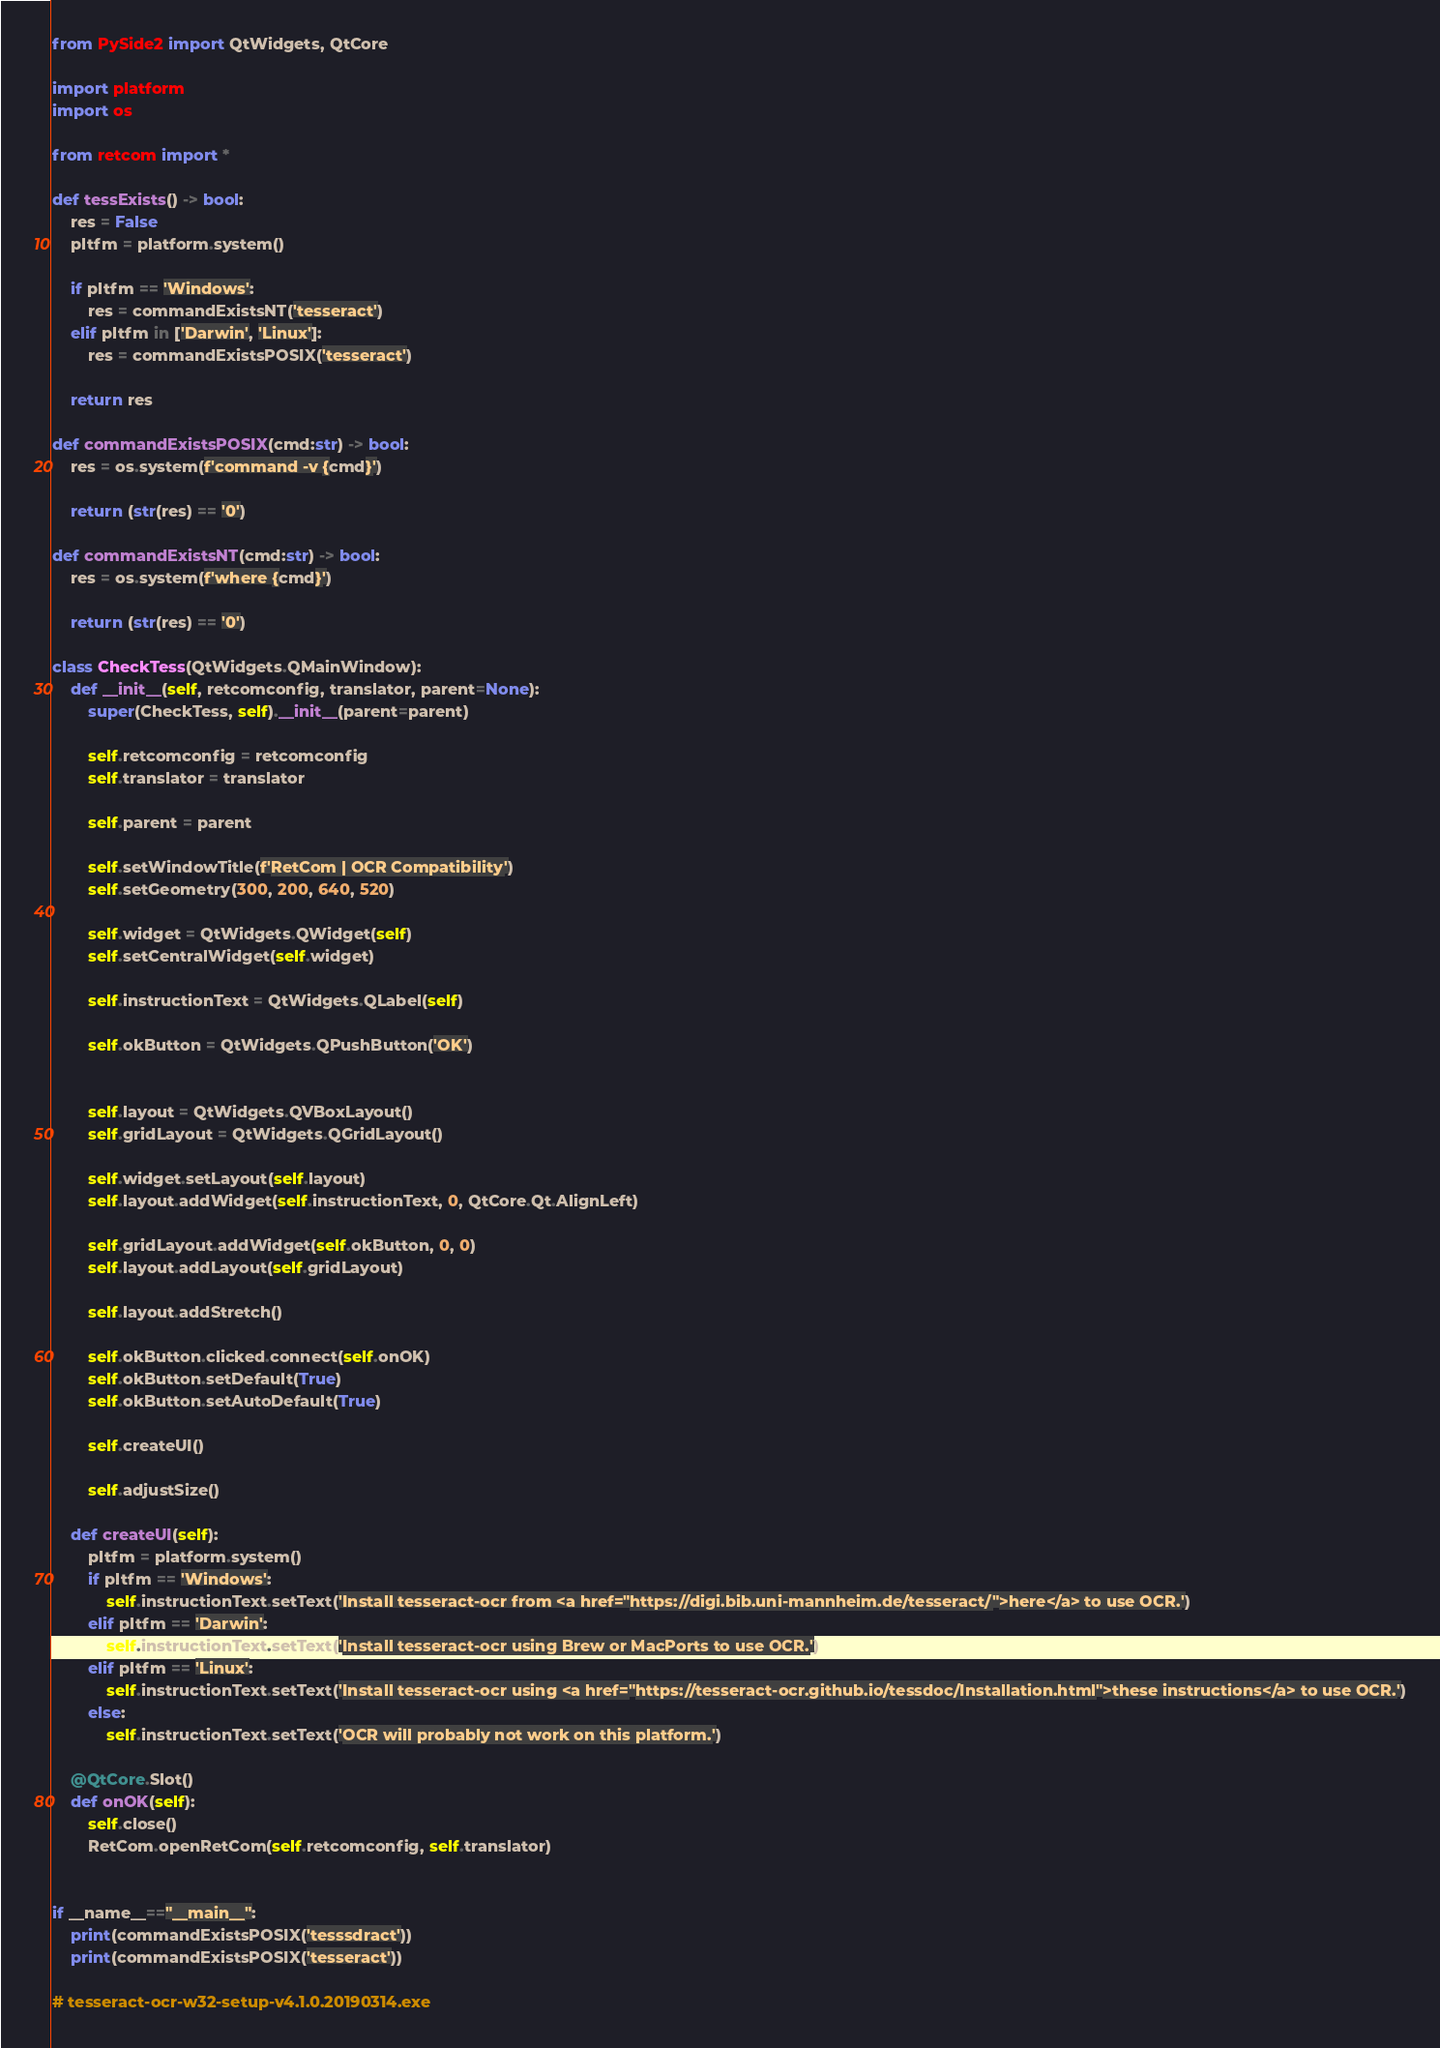Convert code to text. <code><loc_0><loc_0><loc_500><loc_500><_Python_>from PySide2 import QtWidgets, QtCore

import platform
import os

from retcom import *

def tessExists() -> bool:
    res = False
    pltfm = platform.system()

    if pltfm == 'Windows':
        res = commandExistsNT('tesseract')
    elif pltfm in ['Darwin', 'Linux']:
        res = commandExistsPOSIX('tesseract')

    return res

def commandExistsPOSIX(cmd:str) -> bool:
    res = os.system(f'command -v {cmd}')

    return (str(res) == '0')

def commandExistsNT(cmd:str) -> bool:
    res = os.system(f'where {cmd}')

    return (str(res) == '0')

class CheckTess(QtWidgets.QMainWindow):
    def __init__(self, retcomconfig, translator, parent=None):
        super(CheckTess, self).__init__(parent=parent)

        self.retcomconfig = retcomconfig
        self.translator = translator

        self.parent = parent

        self.setWindowTitle(f'RetCom | OCR Compatibility')
        self.setGeometry(300, 200, 640, 520)

        self.widget = QtWidgets.QWidget(self)
        self.setCentralWidget(self.widget)

        self.instructionText = QtWidgets.QLabel(self)

        self.okButton = QtWidgets.QPushButton('OK')


        self.layout = QtWidgets.QVBoxLayout()
        self.gridLayout = QtWidgets.QGridLayout()

        self.widget.setLayout(self.layout)
        self.layout.addWidget(self.instructionText, 0, QtCore.Qt.AlignLeft)

        self.gridLayout.addWidget(self.okButton, 0, 0)
        self.layout.addLayout(self.gridLayout)

        self.layout.addStretch()

        self.okButton.clicked.connect(self.onOK)
        self.okButton.setDefault(True)
        self.okButton.setAutoDefault(True)

        self.createUI()

        self.adjustSize()

    def createUI(self):
        pltfm = platform.system()
        if pltfm == 'Windows':
            self.instructionText.setText('Install tesseract-ocr from <a href="https://digi.bib.uni-mannheim.de/tesseract/">here</a> to use OCR.')
        elif pltfm == 'Darwin':
            self.instructionText.setText('Install tesseract-ocr using Brew or MacPorts to use OCR.')
        elif pltfm == 'Linux':
            self.instructionText.setText('Install tesseract-ocr using <a href="https://tesseract-ocr.github.io/tessdoc/Installation.html">these instructions</a> to use OCR.')
        else:
            self.instructionText.setText('OCR will probably not work on this platform.')

    @QtCore.Slot()
    def onOK(self):
        self.close()
        RetCom.openRetCom(self.retcomconfig, self.translator)


if __name__=="__main__":
    print(commandExistsPOSIX('tesssdract'))
    print(commandExistsPOSIX('tesseract'))

# tesseract-ocr-w32-setup-v4.1.0.20190314.exe</code> 